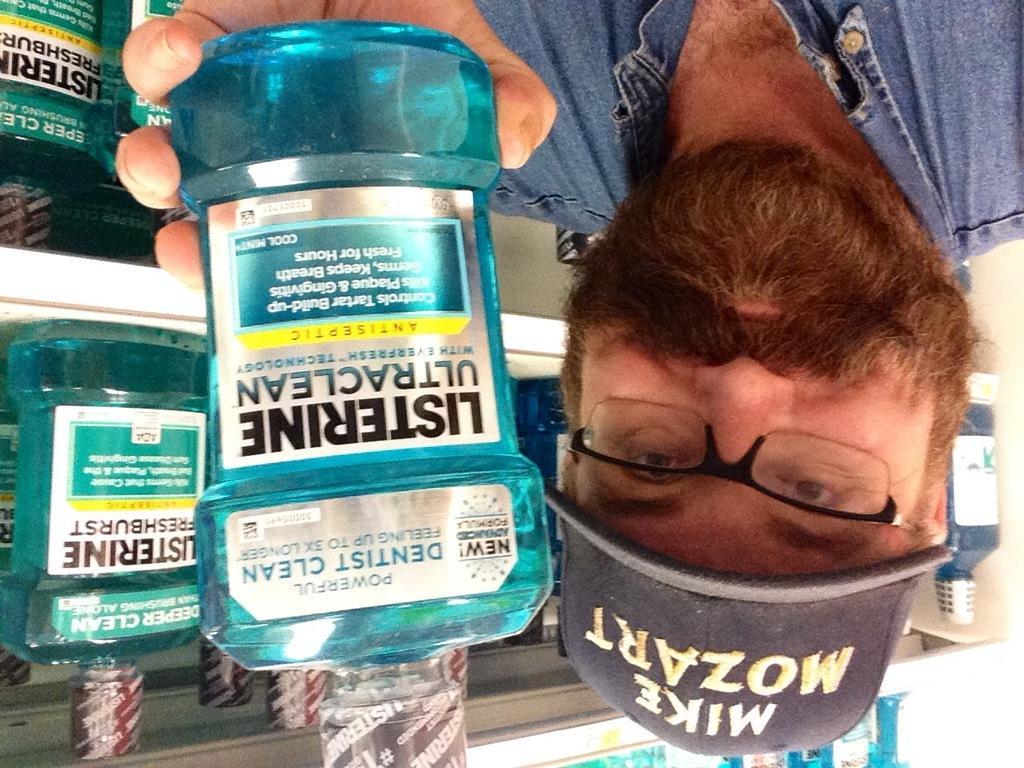What is the main subject in the foreground of the picture? There is a person in the foreground of the picture. What is the person holding in the picture? The person is holding a plastic bottle. What can be seen behind the person in the picture? There are bottles in racks behind the person. What accessories is the person wearing in the picture? The person is wearing spectacles and a cap. What type of box is being stitched by the person in the image? There is no box or stitching activity present in the image. 